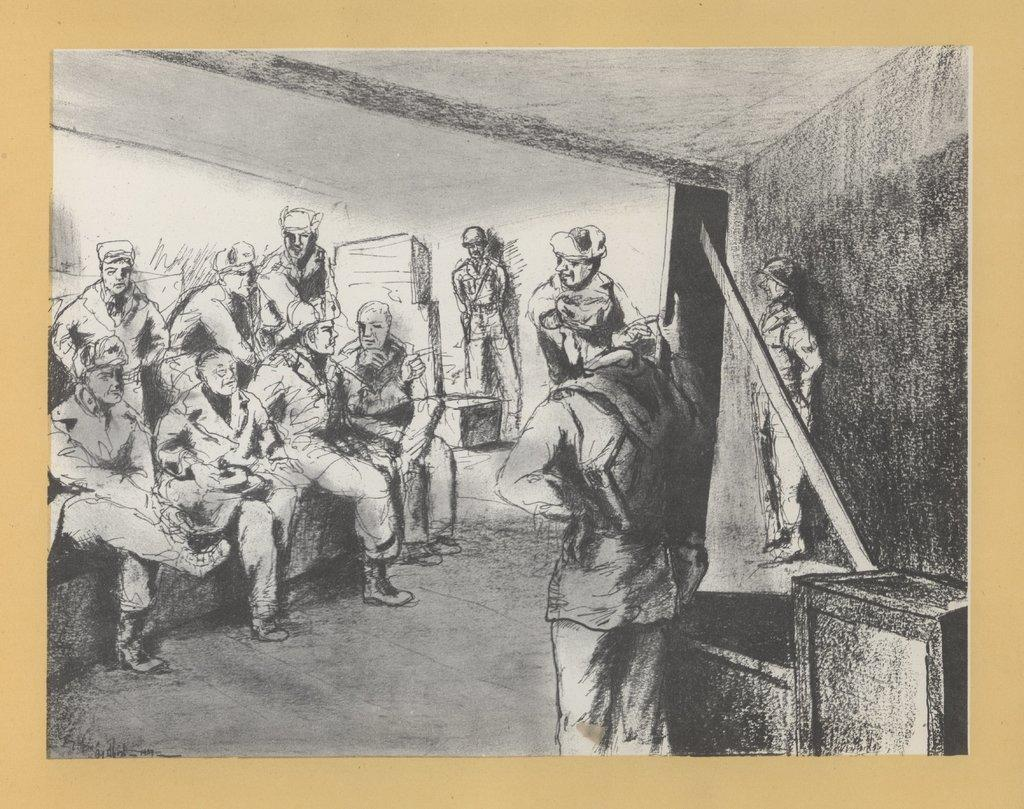What type of image is shown in the picture? The image contains a black and white drawing. What is the subject of the drawing? The drawing depicts a group of people sitting. Are there any other people in the drawing besides those sitting? Yes, there are people standing on the right side of the drawing. Where are the people in the drawing located? The people are on the floor. What type of mailbox can be seen in the drawing? There is no mailbox present in the drawing; it depicts a group of people sitting and standing on the floor. 